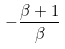<formula> <loc_0><loc_0><loc_500><loc_500>- \frac { \beta + 1 } { \beta }</formula> 